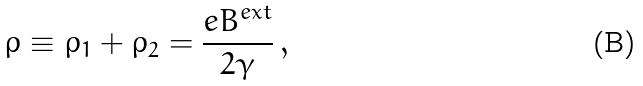<formula> <loc_0><loc_0><loc_500><loc_500>\rho \equiv \rho _ { 1 } + \rho _ { 2 } = \frac { e B ^ { e x t } } { 2 \gamma } \, ,</formula> 